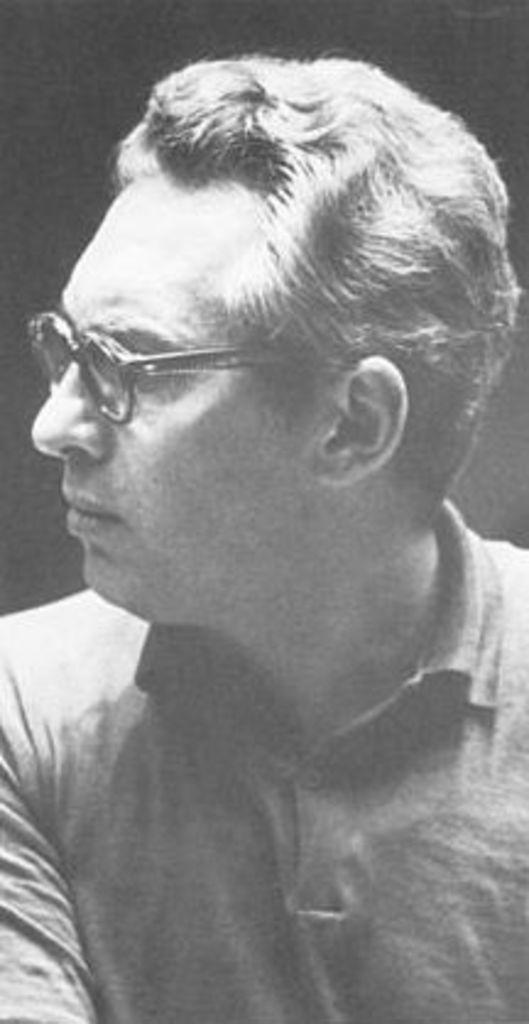What is the color scheme of the image? The image is in black and white. Who is present in the picture? There is a man in the picture. What is the man wearing on his upper body? The man is wearing a t-shirt. What accessory is the man wearing on his face? The man is wearing spectacles. What is the man's reaction to the animal in the image? There is no animal present in the image, so the man's reaction cannot be determined. 